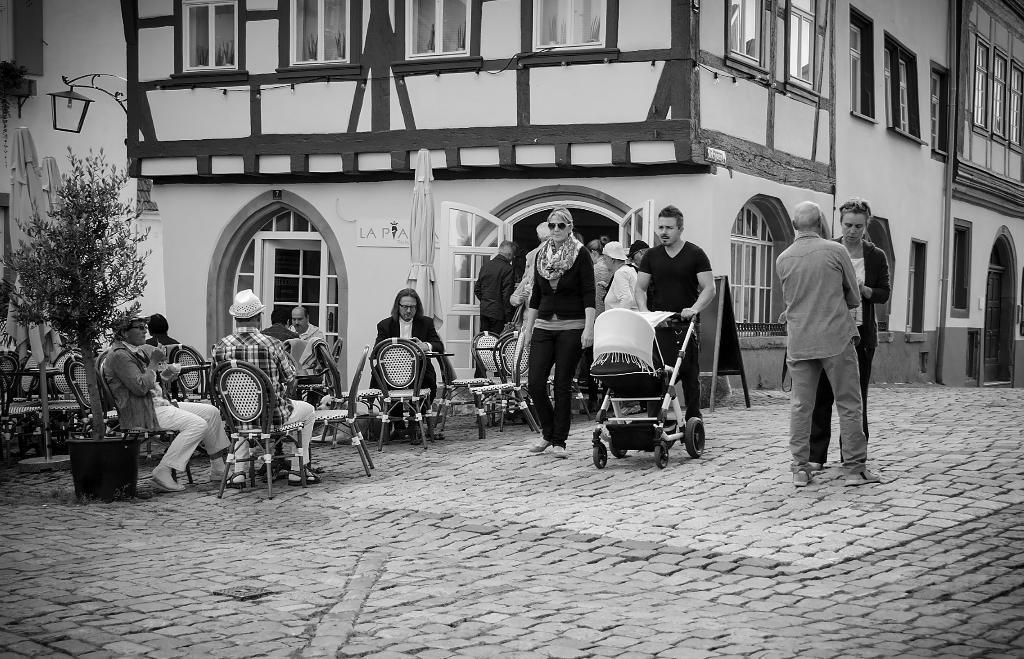Could you give a brief overview of what you see in this image? This picture is clicked outside. On the right we can see the two persons standing on the pavement and we can see a man wearing t-shirt and seems to be pushing the stroller and we can see the group of people and we can see the chairs and group of people sitting on the chairs. In the background we can see the buildings, tree and some other objects and this picture seems to be a black and white image. 